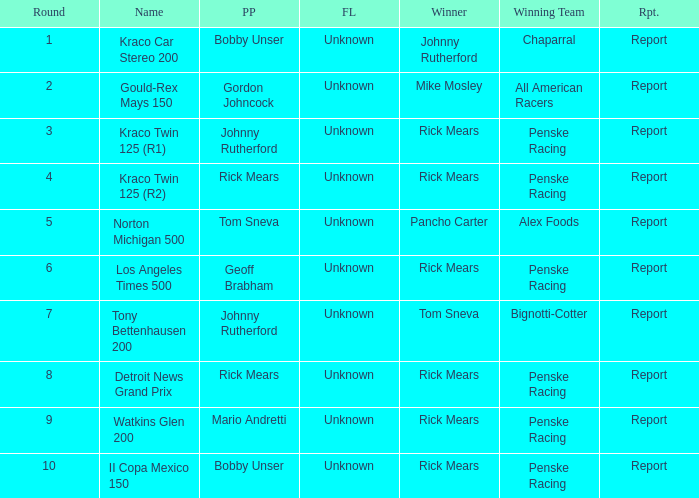The race tony bettenhausen 200 has what smallest rd? 7.0. 